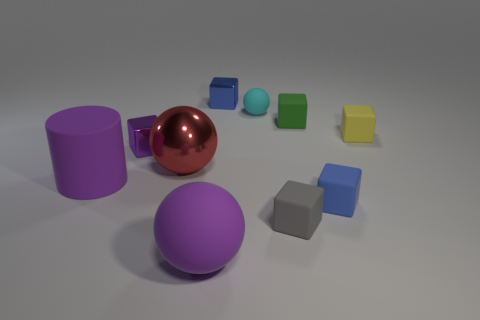Subtract 3 cubes. How many cubes are left? 3 Subtract all purple blocks. How many blocks are left? 5 Subtract all purple shiny blocks. How many blocks are left? 5 Subtract all green cubes. Subtract all yellow balls. How many cubes are left? 5 Subtract all balls. How many objects are left? 7 Subtract 1 purple cylinders. How many objects are left? 9 Subtract all yellow blocks. Subtract all small blue shiny things. How many objects are left? 8 Add 2 blocks. How many blocks are left? 8 Add 2 cyan rubber cubes. How many cyan rubber cubes exist? 2 